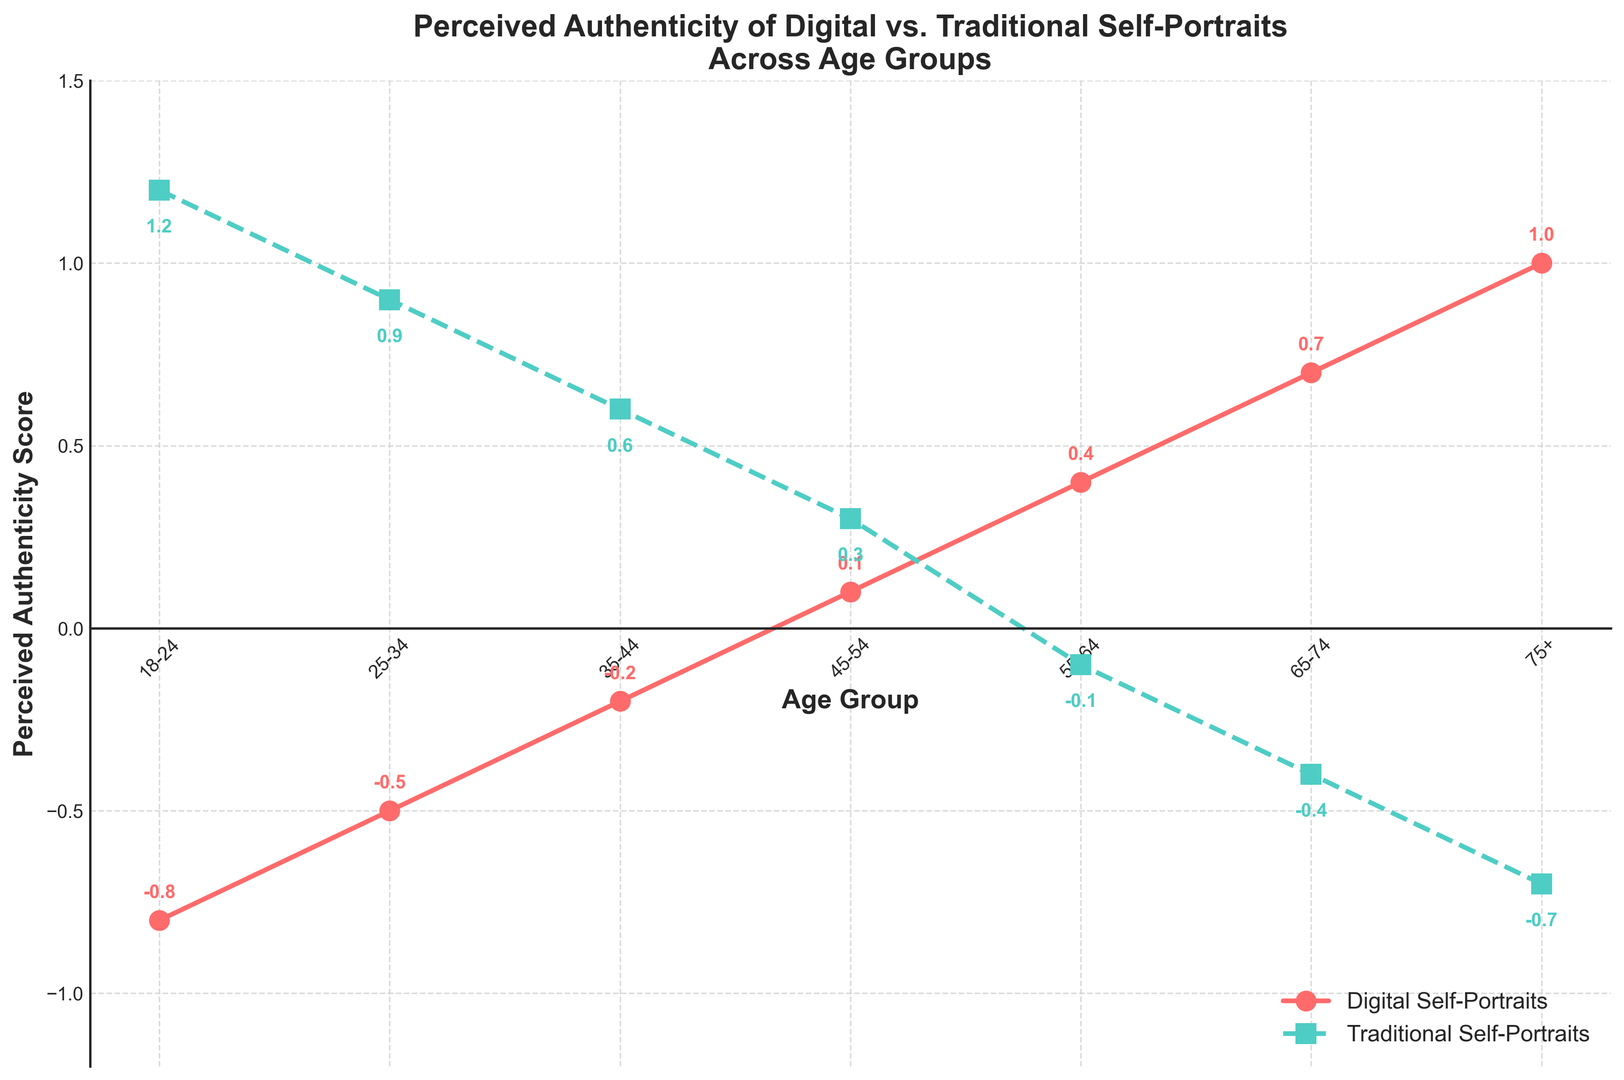Question: What is the perceived authenticity score for digital self-portraits for the age group 35-44? Explanation: Look at the point on the line representing digital self-portraits (red line) corresponding to the age group 35-44. The value at that point is -0.2.
Answer: -0.2 Question: In which age group do digital self-portraits and traditional self-portraits have the same perceived authenticity score? Explanation: For digital and traditional self-portraits to have the same score, their points must match on the vertical axis. Reviewing the values, there is no age group where both scores are equal.
Answer: None Question: Which has a higher perceived authenticity score in the 18-24 age group, digital self-portraits or traditional self-portraits? Explanation: Compare the values for the 18-24 age group. Digital self-portraits have a score of -0.8, and traditional self-portraits have a score of 1.2. Since 1.2 is greater than -0.8, traditional self-portraits have a higher score.
Answer: Traditional self-portraits Question: What is the trend of perceived authenticity scores of digital self-portraits as age increases? Explanation: Observe the plot of digital self-portraits (red line) from age group 18-24 to 75+. The values consistently increase as age increases.
Answer: Increasing Question: What's the difference in perceived authenticity scores between the age groups 55-64 and 65-74 for traditional self-portraits? Explanation: Subtract the score of traditional self-portraits for 65-74 (-0.4) from the score for 55-64 (-0.1): -0.4 - (-0.1) = -0.3.
Answer: -0.3 Question: Which age group shows the greatest contrast in perceived authenticity between digital and traditional self-portraits? Explanation: Calculate the absolute differences between digital and traditional scores for each age group and find the maximum. The differences are 2.0, 1.4, 0.8, 0.2, 0.5, 1.1, and 1.7, respectively. The greatest contrast is 2.0 for the age group 18-24.
Answer: 18-24 Question: How does the perceived authenticity score for traditional self-portraits change from the age group 55-64 to 75+? Explanation: Look at the green line values for age groups 55-64 (-0.1), 65-74 (-0.4), and 75+ (-0.7). The values decrease continuously as age increases.
Answer: Decreasing Question: What are the scores for digital and traditional self-portraits in the age group 75+? Explanation: Refer to the endpoints of the lines for the 75+ age group. Digital score is 1.0, and traditional score is -0.7.
Answer: 1.0 and -0.7 